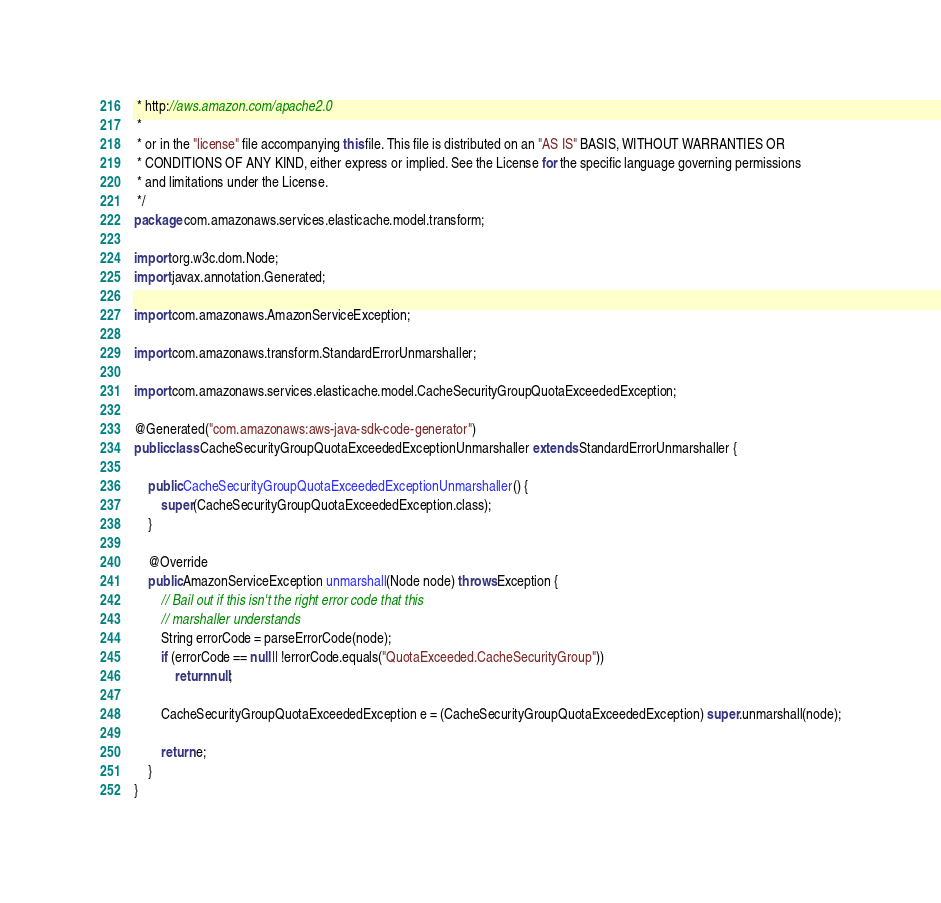<code> <loc_0><loc_0><loc_500><loc_500><_Java_> * http://aws.amazon.com/apache2.0
 * 
 * or in the "license" file accompanying this file. This file is distributed on an "AS IS" BASIS, WITHOUT WARRANTIES OR
 * CONDITIONS OF ANY KIND, either express or implied. See the License for the specific language governing permissions
 * and limitations under the License.
 */
package com.amazonaws.services.elasticache.model.transform;

import org.w3c.dom.Node;
import javax.annotation.Generated;

import com.amazonaws.AmazonServiceException;

import com.amazonaws.transform.StandardErrorUnmarshaller;

import com.amazonaws.services.elasticache.model.CacheSecurityGroupQuotaExceededException;

@Generated("com.amazonaws:aws-java-sdk-code-generator")
public class CacheSecurityGroupQuotaExceededExceptionUnmarshaller extends StandardErrorUnmarshaller {

    public CacheSecurityGroupQuotaExceededExceptionUnmarshaller() {
        super(CacheSecurityGroupQuotaExceededException.class);
    }

    @Override
    public AmazonServiceException unmarshall(Node node) throws Exception {
        // Bail out if this isn't the right error code that this
        // marshaller understands
        String errorCode = parseErrorCode(node);
        if (errorCode == null || !errorCode.equals("QuotaExceeded.CacheSecurityGroup"))
            return null;

        CacheSecurityGroupQuotaExceededException e = (CacheSecurityGroupQuotaExceededException) super.unmarshall(node);

        return e;
    }
}
</code> 